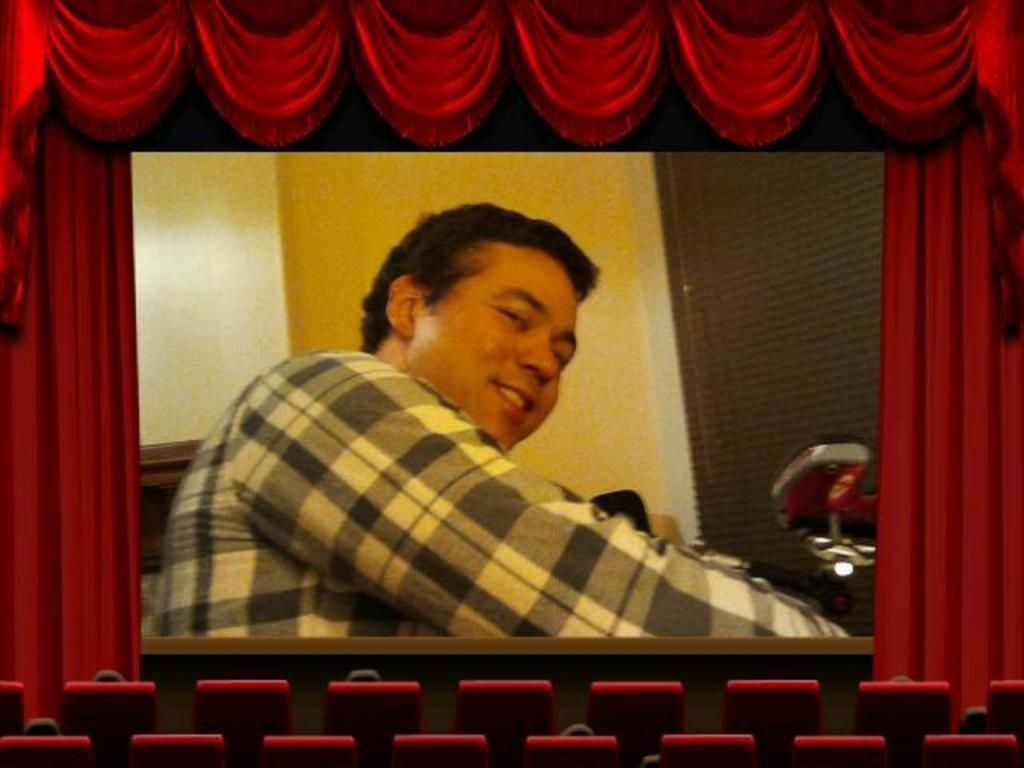Can you describe this image briefly? In this image there are chairs, screen and curtains. I can see a person's face and objects on the screen.   